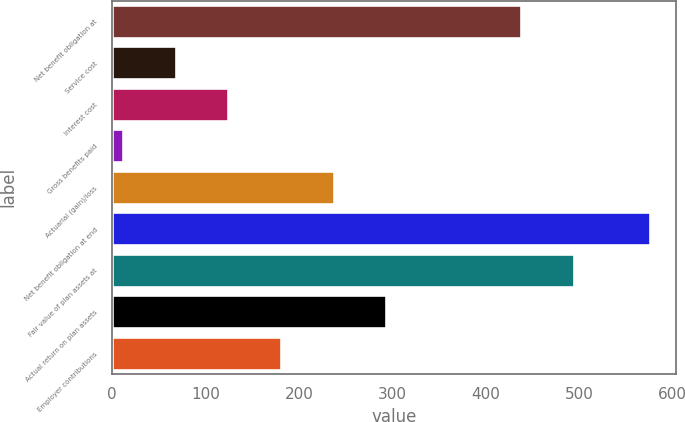<chart> <loc_0><loc_0><loc_500><loc_500><bar_chart><fcel>Net benefit obligation at<fcel>Service cost<fcel>Interest cost<fcel>Gross benefits paid<fcel>Actuarial (gain)/loss<fcel>Net benefit obligation at end<fcel>Fair value of plan assets at<fcel>Actual return on plan assets<fcel>Employer contributions<nl><fcel>438<fcel>68.3<fcel>124.6<fcel>12<fcel>237.2<fcel>575<fcel>494.3<fcel>293.5<fcel>180.9<nl></chart> 